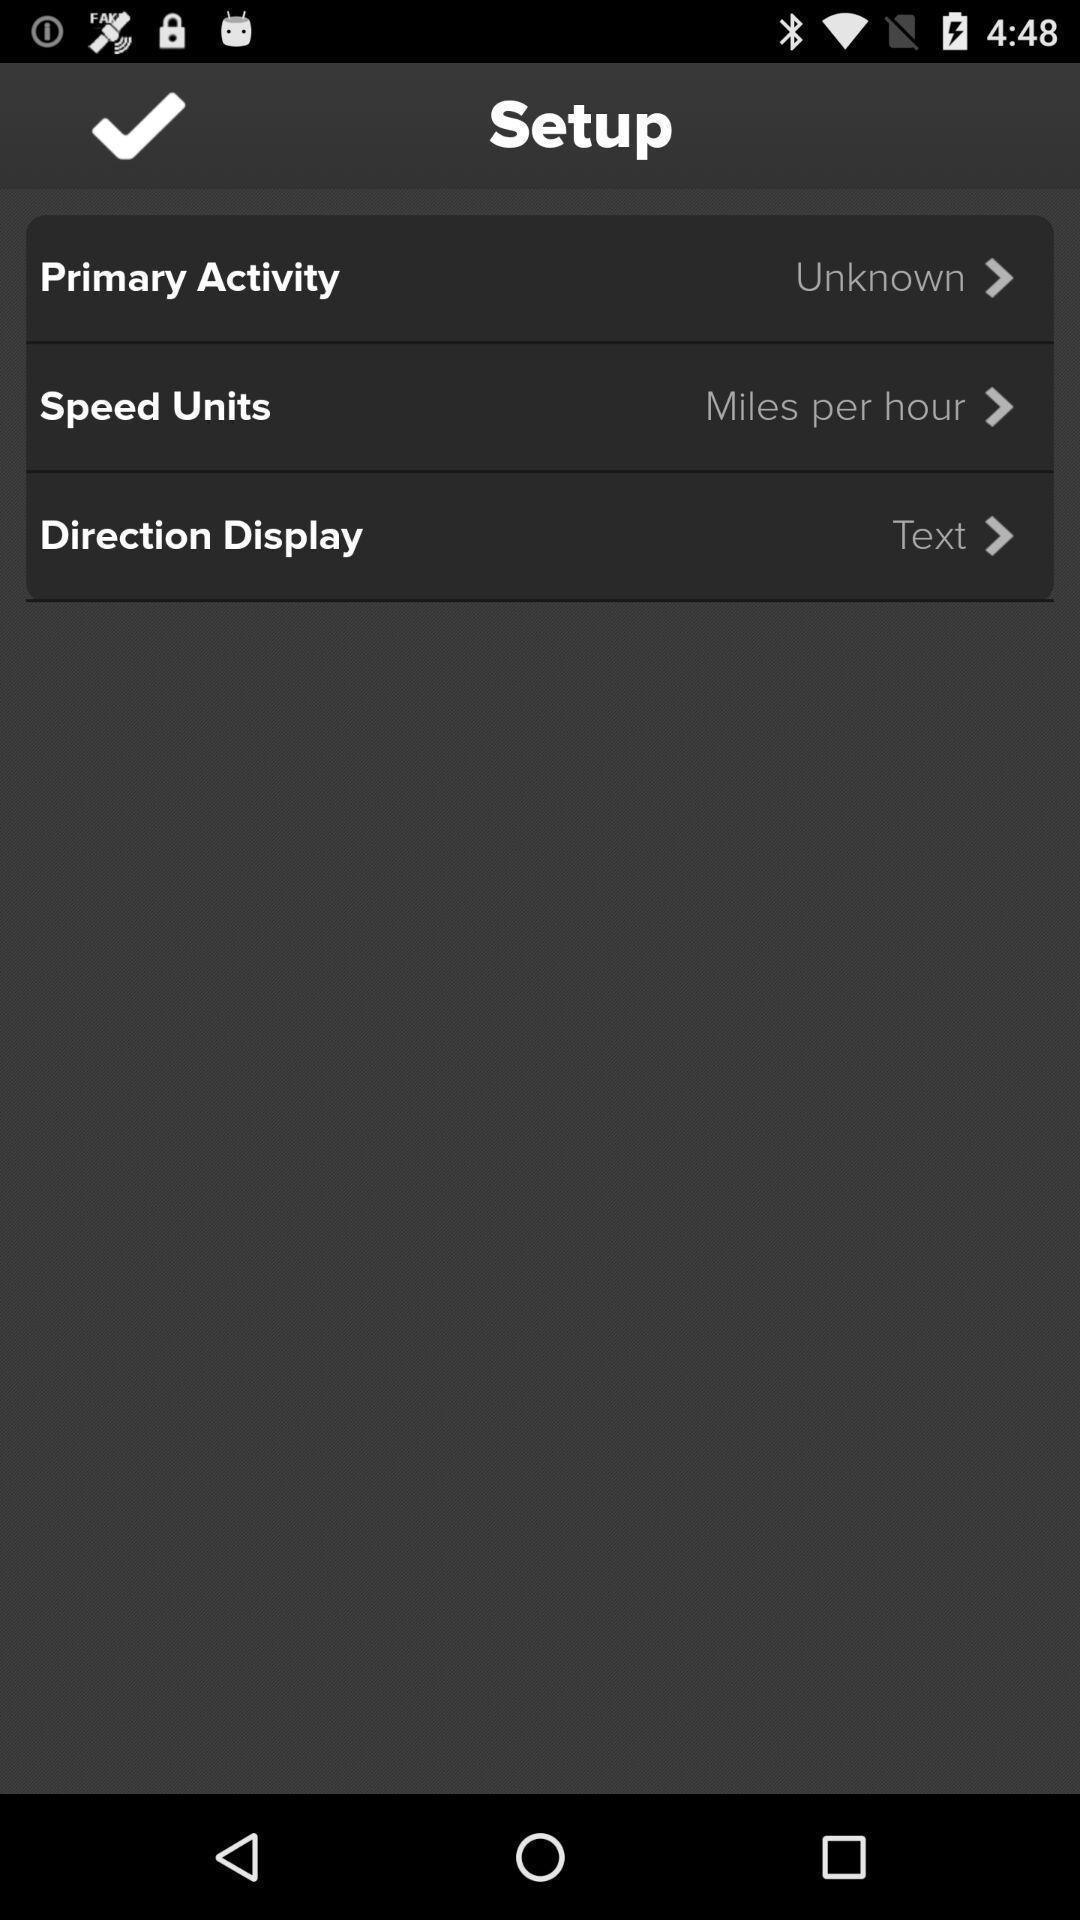Give me a narrative description of this picture. Screen showing multiple options to setup. 